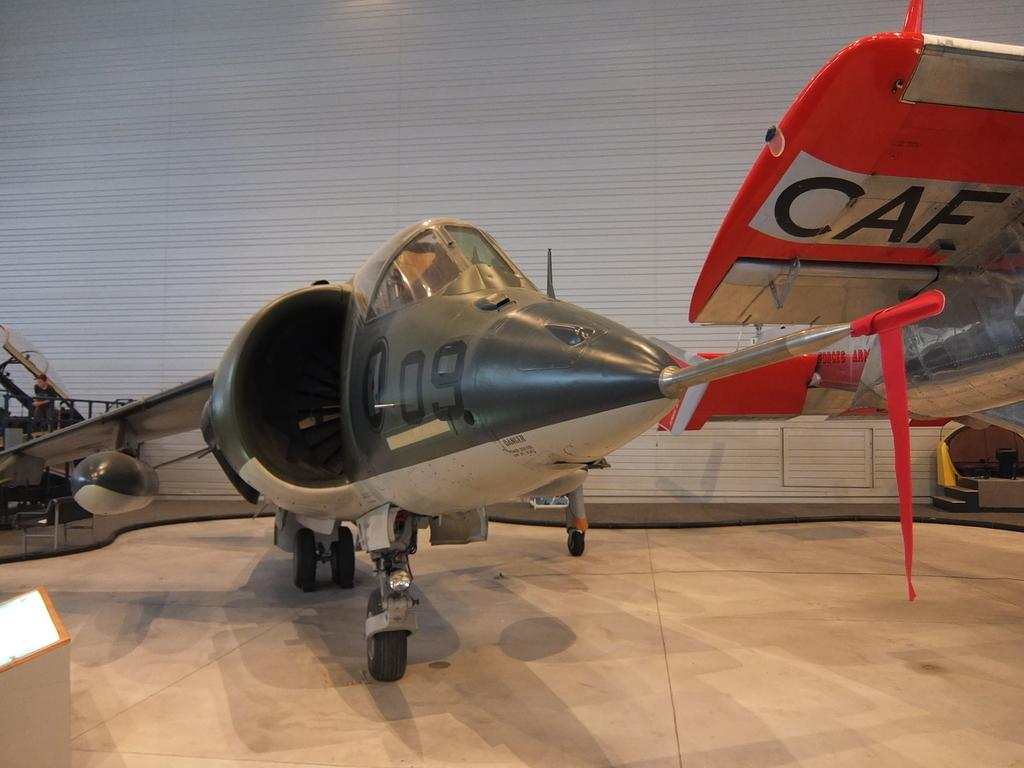Provide a one-sentence caption for the provided image. Plane number 09 sits next to a plane with CAF on the wing. 